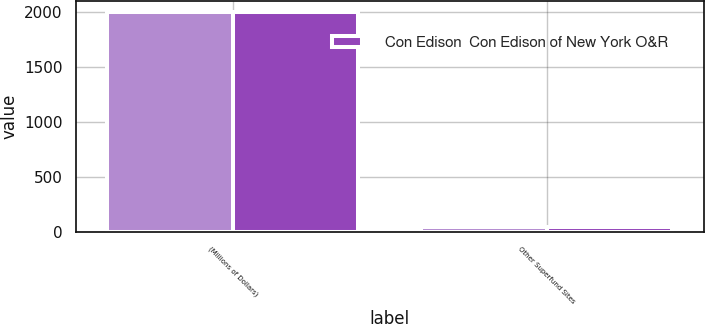Convert chart to OTSL. <chart><loc_0><loc_0><loc_500><loc_500><stacked_bar_chart><ecel><fcel>(Millions of Dollars)<fcel>Other Superfund Sites<nl><fcel>nan<fcel>2003<fcel>48<nl><fcel>Con Edison  Con Edison of New York O&R<fcel>2003<fcel>47<nl></chart> 